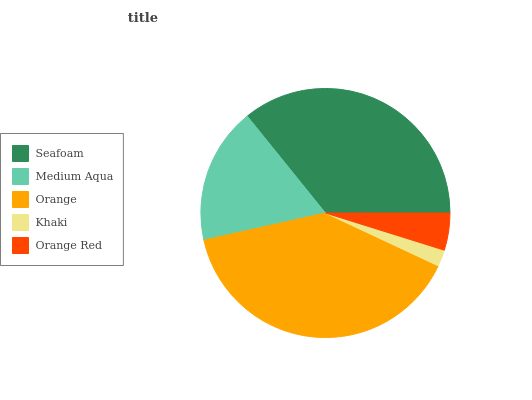Is Khaki the minimum?
Answer yes or no. Yes. Is Orange the maximum?
Answer yes or no. Yes. Is Medium Aqua the minimum?
Answer yes or no. No. Is Medium Aqua the maximum?
Answer yes or no. No. Is Seafoam greater than Medium Aqua?
Answer yes or no. Yes. Is Medium Aqua less than Seafoam?
Answer yes or no. Yes. Is Medium Aqua greater than Seafoam?
Answer yes or no. No. Is Seafoam less than Medium Aqua?
Answer yes or no. No. Is Medium Aqua the high median?
Answer yes or no. Yes. Is Medium Aqua the low median?
Answer yes or no. Yes. Is Khaki the high median?
Answer yes or no. No. Is Khaki the low median?
Answer yes or no. No. 